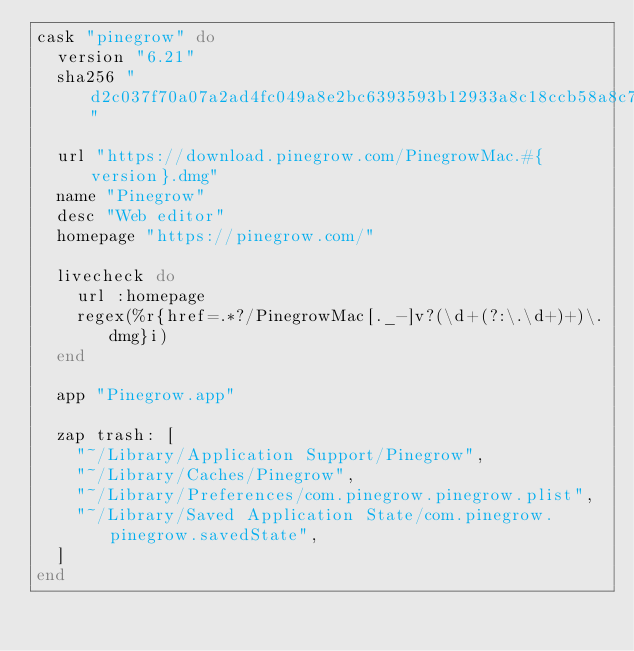<code> <loc_0><loc_0><loc_500><loc_500><_Ruby_>cask "pinegrow" do
  version "6.21"
  sha256 "d2c037f70a07a2ad4fc049a8e2bc6393593b12933a8c18ccb58a8c713899f9d5"

  url "https://download.pinegrow.com/PinegrowMac.#{version}.dmg"
  name "Pinegrow"
  desc "Web editor"
  homepage "https://pinegrow.com/"

  livecheck do
    url :homepage
    regex(%r{href=.*?/PinegrowMac[._-]v?(\d+(?:\.\d+)+)\.dmg}i)
  end

  app "Pinegrow.app"

  zap trash: [
    "~/Library/Application Support/Pinegrow",
    "~/Library/Caches/Pinegrow",
    "~/Library/Preferences/com.pinegrow.pinegrow.plist",
    "~/Library/Saved Application State/com.pinegrow.pinegrow.savedState",
  ]
end
</code> 